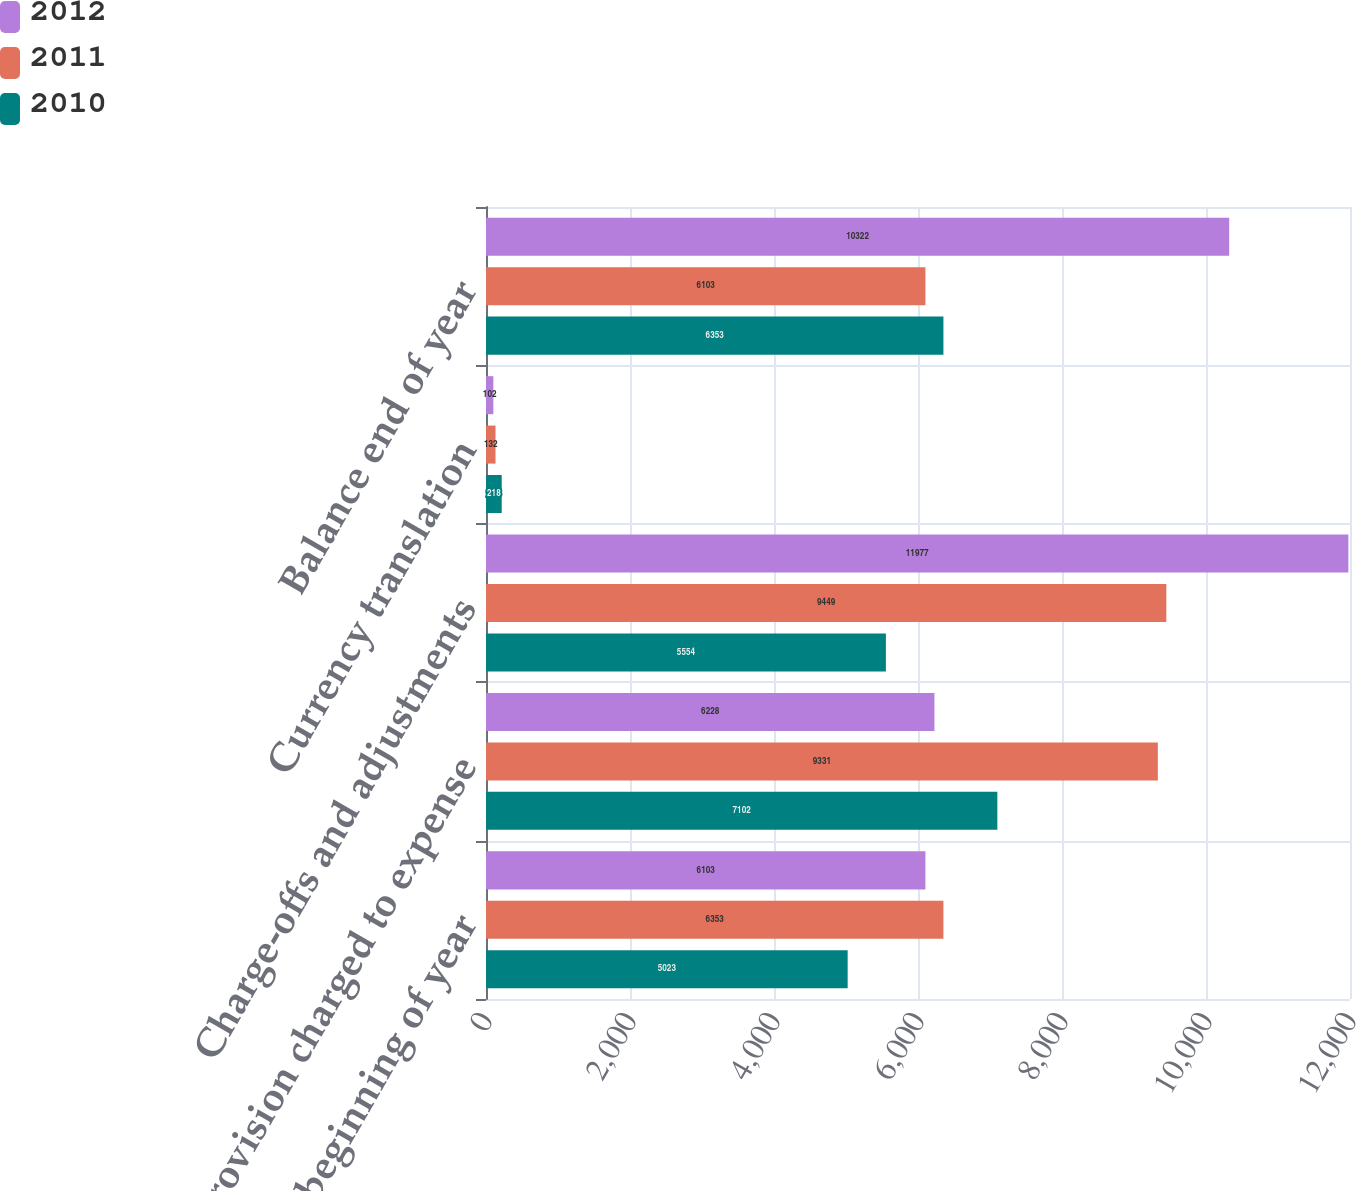Convert chart to OTSL. <chart><loc_0><loc_0><loc_500><loc_500><stacked_bar_chart><ecel><fcel>Balance beginning of year<fcel>Provision charged to expense<fcel>Charge-offs and adjustments<fcel>Currency translation<fcel>Balance end of year<nl><fcel>2012<fcel>6103<fcel>6228<fcel>11977<fcel>102<fcel>10322<nl><fcel>2011<fcel>6353<fcel>9331<fcel>9449<fcel>132<fcel>6103<nl><fcel>2010<fcel>5023<fcel>7102<fcel>5554<fcel>218<fcel>6353<nl></chart> 